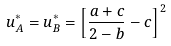Convert formula to latex. <formula><loc_0><loc_0><loc_500><loc_500>u _ { A } ^ { \ast } = u _ { B } ^ { \ast } = \left [ \frac { a + c } { 2 - b } - c \right ] ^ { 2 }</formula> 